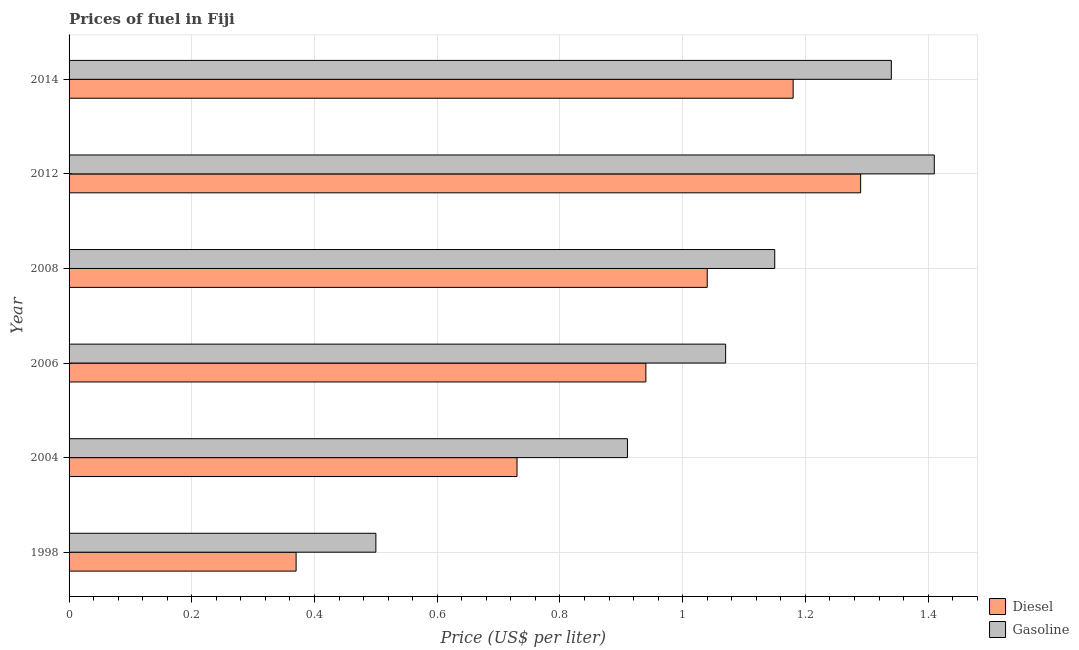How many groups of bars are there?
Give a very brief answer. 6. Are the number of bars per tick equal to the number of legend labels?
Your response must be concise. Yes. Are the number of bars on each tick of the Y-axis equal?
Your response must be concise. Yes. How many bars are there on the 6th tick from the top?
Your answer should be very brief. 2. How many bars are there on the 1st tick from the bottom?
Provide a succinct answer. 2. What is the gasoline price in 2014?
Make the answer very short. 1.34. Across all years, what is the maximum diesel price?
Keep it short and to the point. 1.29. Across all years, what is the minimum diesel price?
Your answer should be compact. 0.37. In which year was the diesel price maximum?
Give a very brief answer. 2012. In which year was the diesel price minimum?
Your response must be concise. 1998. What is the total gasoline price in the graph?
Your response must be concise. 6.38. What is the difference between the gasoline price in 2004 and that in 2008?
Provide a succinct answer. -0.24. What is the difference between the gasoline price in 2008 and the diesel price in 2004?
Offer a very short reply. 0.42. What is the average diesel price per year?
Provide a short and direct response. 0.93. In the year 2006, what is the difference between the gasoline price and diesel price?
Provide a short and direct response. 0.13. What is the ratio of the diesel price in 2008 to that in 2012?
Make the answer very short. 0.81. Is the gasoline price in 2012 less than that in 2014?
Your answer should be very brief. No. Is the difference between the gasoline price in 2004 and 2008 greater than the difference between the diesel price in 2004 and 2008?
Provide a succinct answer. Yes. What is the difference between the highest and the second highest gasoline price?
Offer a terse response. 0.07. What is the difference between the highest and the lowest gasoline price?
Your response must be concise. 0.91. In how many years, is the diesel price greater than the average diesel price taken over all years?
Your answer should be compact. 4. Is the sum of the diesel price in 1998 and 2014 greater than the maximum gasoline price across all years?
Provide a short and direct response. Yes. What does the 1st bar from the top in 2006 represents?
Your response must be concise. Gasoline. What does the 1st bar from the bottom in 2008 represents?
Make the answer very short. Diesel. How many years are there in the graph?
Provide a short and direct response. 6. What is the difference between two consecutive major ticks on the X-axis?
Your answer should be very brief. 0.2. Where does the legend appear in the graph?
Offer a terse response. Bottom right. What is the title of the graph?
Provide a short and direct response. Prices of fuel in Fiji. Does "RDB concessional" appear as one of the legend labels in the graph?
Provide a succinct answer. No. What is the label or title of the X-axis?
Offer a terse response. Price (US$ per liter). What is the label or title of the Y-axis?
Make the answer very short. Year. What is the Price (US$ per liter) in Diesel in 1998?
Offer a very short reply. 0.37. What is the Price (US$ per liter) in Gasoline in 1998?
Offer a terse response. 0.5. What is the Price (US$ per liter) of Diesel in 2004?
Your response must be concise. 0.73. What is the Price (US$ per liter) in Gasoline in 2004?
Make the answer very short. 0.91. What is the Price (US$ per liter) of Gasoline in 2006?
Offer a terse response. 1.07. What is the Price (US$ per liter) of Diesel in 2008?
Your answer should be compact. 1.04. What is the Price (US$ per liter) in Gasoline in 2008?
Ensure brevity in your answer.  1.15. What is the Price (US$ per liter) in Diesel in 2012?
Your answer should be very brief. 1.29. What is the Price (US$ per liter) of Gasoline in 2012?
Give a very brief answer. 1.41. What is the Price (US$ per liter) in Diesel in 2014?
Provide a succinct answer. 1.18. What is the Price (US$ per liter) in Gasoline in 2014?
Provide a short and direct response. 1.34. Across all years, what is the maximum Price (US$ per liter) of Diesel?
Provide a short and direct response. 1.29. Across all years, what is the maximum Price (US$ per liter) in Gasoline?
Keep it short and to the point. 1.41. Across all years, what is the minimum Price (US$ per liter) in Diesel?
Ensure brevity in your answer.  0.37. Across all years, what is the minimum Price (US$ per liter) in Gasoline?
Provide a short and direct response. 0.5. What is the total Price (US$ per liter) in Diesel in the graph?
Give a very brief answer. 5.55. What is the total Price (US$ per liter) of Gasoline in the graph?
Your answer should be compact. 6.38. What is the difference between the Price (US$ per liter) in Diesel in 1998 and that in 2004?
Offer a very short reply. -0.36. What is the difference between the Price (US$ per liter) of Gasoline in 1998 and that in 2004?
Provide a succinct answer. -0.41. What is the difference between the Price (US$ per liter) in Diesel in 1998 and that in 2006?
Your answer should be very brief. -0.57. What is the difference between the Price (US$ per liter) in Gasoline in 1998 and that in 2006?
Provide a short and direct response. -0.57. What is the difference between the Price (US$ per liter) in Diesel in 1998 and that in 2008?
Provide a succinct answer. -0.67. What is the difference between the Price (US$ per liter) in Gasoline in 1998 and that in 2008?
Offer a terse response. -0.65. What is the difference between the Price (US$ per liter) of Diesel in 1998 and that in 2012?
Ensure brevity in your answer.  -0.92. What is the difference between the Price (US$ per liter) in Gasoline in 1998 and that in 2012?
Your response must be concise. -0.91. What is the difference between the Price (US$ per liter) in Diesel in 1998 and that in 2014?
Ensure brevity in your answer.  -0.81. What is the difference between the Price (US$ per liter) of Gasoline in 1998 and that in 2014?
Keep it short and to the point. -0.84. What is the difference between the Price (US$ per liter) of Diesel in 2004 and that in 2006?
Provide a short and direct response. -0.21. What is the difference between the Price (US$ per liter) of Gasoline in 2004 and that in 2006?
Provide a short and direct response. -0.16. What is the difference between the Price (US$ per liter) in Diesel in 2004 and that in 2008?
Make the answer very short. -0.31. What is the difference between the Price (US$ per liter) of Gasoline in 2004 and that in 2008?
Provide a short and direct response. -0.24. What is the difference between the Price (US$ per liter) of Diesel in 2004 and that in 2012?
Provide a short and direct response. -0.56. What is the difference between the Price (US$ per liter) of Gasoline in 2004 and that in 2012?
Provide a short and direct response. -0.5. What is the difference between the Price (US$ per liter) of Diesel in 2004 and that in 2014?
Provide a short and direct response. -0.45. What is the difference between the Price (US$ per liter) of Gasoline in 2004 and that in 2014?
Provide a short and direct response. -0.43. What is the difference between the Price (US$ per liter) of Diesel in 2006 and that in 2008?
Offer a very short reply. -0.1. What is the difference between the Price (US$ per liter) of Gasoline in 2006 and that in 2008?
Ensure brevity in your answer.  -0.08. What is the difference between the Price (US$ per liter) in Diesel in 2006 and that in 2012?
Your answer should be very brief. -0.35. What is the difference between the Price (US$ per liter) of Gasoline in 2006 and that in 2012?
Ensure brevity in your answer.  -0.34. What is the difference between the Price (US$ per liter) of Diesel in 2006 and that in 2014?
Offer a very short reply. -0.24. What is the difference between the Price (US$ per liter) of Gasoline in 2006 and that in 2014?
Offer a terse response. -0.27. What is the difference between the Price (US$ per liter) of Diesel in 2008 and that in 2012?
Keep it short and to the point. -0.25. What is the difference between the Price (US$ per liter) of Gasoline in 2008 and that in 2012?
Ensure brevity in your answer.  -0.26. What is the difference between the Price (US$ per liter) in Diesel in 2008 and that in 2014?
Give a very brief answer. -0.14. What is the difference between the Price (US$ per liter) in Gasoline in 2008 and that in 2014?
Offer a very short reply. -0.19. What is the difference between the Price (US$ per liter) of Diesel in 2012 and that in 2014?
Offer a terse response. 0.11. What is the difference between the Price (US$ per liter) of Gasoline in 2012 and that in 2014?
Make the answer very short. 0.07. What is the difference between the Price (US$ per liter) of Diesel in 1998 and the Price (US$ per liter) of Gasoline in 2004?
Keep it short and to the point. -0.54. What is the difference between the Price (US$ per liter) of Diesel in 1998 and the Price (US$ per liter) of Gasoline in 2006?
Your answer should be very brief. -0.7. What is the difference between the Price (US$ per liter) of Diesel in 1998 and the Price (US$ per liter) of Gasoline in 2008?
Make the answer very short. -0.78. What is the difference between the Price (US$ per liter) of Diesel in 1998 and the Price (US$ per liter) of Gasoline in 2012?
Keep it short and to the point. -1.04. What is the difference between the Price (US$ per liter) of Diesel in 1998 and the Price (US$ per liter) of Gasoline in 2014?
Keep it short and to the point. -0.97. What is the difference between the Price (US$ per liter) of Diesel in 2004 and the Price (US$ per liter) of Gasoline in 2006?
Offer a terse response. -0.34. What is the difference between the Price (US$ per liter) in Diesel in 2004 and the Price (US$ per liter) in Gasoline in 2008?
Your answer should be compact. -0.42. What is the difference between the Price (US$ per liter) in Diesel in 2004 and the Price (US$ per liter) in Gasoline in 2012?
Give a very brief answer. -0.68. What is the difference between the Price (US$ per liter) in Diesel in 2004 and the Price (US$ per liter) in Gasoline in 2014?
Provide a short and direct response. -0.61. What is the difference between the Price (US$ per liter) of Diesel in 2006 and the Price (US$ per liter) of Gasoline in 2008?
Give a very brief answer. -0.21. What is the difference between the Price (US$ per liter) of Diesel in 2006 and the Price (US$ per liter) of Gasoline in 2012?
Give a very brief answer. -0.47. What is the difference between the Price (US$ per liter) in Diesel in 2008 and the Price (US$ per liter) in Gasoline in 2012?
Your response must be concise. -0.37. What is the difference between the Price (US$ per liter) in Diesel in 2008 and the Price (US$ per liter) in Gasoline in 2014?
Your answer should be very brief. -0.3. What is the average Price (US$ per liter) in Diesel per year?
Ensure brevity in your answer.  0.93. What is the average Price (US$ per liter) in Gasoline per year?
Your answer should be compact. 1.06. In the year 1998, what is the difference between the Price (US$ per liter) in Diesel and Price (US$ per liter) in Gasoline?
Your response must be concise. -0.13. In the year 2004, what is the difference between the Price (US$ per liter) in Diesel and Price (US$ per liter) in Gasoline?
Provide a succinct answer. -0.18. In the year 2006, what is the difference between the Price (US$ per liter) in Diesel and Price (US$ per liter) in Gasoline?
Offer a very short reply. -0.13. In the year 2008, what is the difference between the Price (US$ per liter) in Diesel and Price (US$ per liter) in Gasoline?
Keep it short and to the point. -0.11. In the year 2012, what is the difference between the Price (US$ per liter) of Diesel and Price (US$ per liter) of Gasoline?
Make the answer very short. -0.12. In the year 2014, what is the difference between the Price (US$ per liter) of Diesel and Price (US$ per liter) of Gasoline?
Ensure brevity in your answer.  -0.16. What is the ratio of the Price (US$ per liter) of Diesel in 1998 to that in 2004?
Give a very brief answer. 0.51. What is the ratio of the Price (US$ per liter) of Gasoline in 1998 to that in 2004?
Provide a succinct answer. 0.55. What is the ratio of the Price (US$ per liter) in Diesel in 1998 to that in 2006?
Make the answer very short. 0.39. What is the ratio of the Price (US$ per liter) of Gasoline in 1998 to that in 2006?
Provide a short and direct response. 0.47. What is the ratio of the Price (US$ per liter) in Diesel in 1998 to that in 2008?
Offer a very short reply. 0.36. What is the ratio of the Price (US$ per liter) of Gasoline in 1998 to that in 2008?
Give a very brief answer. 0.43. What is the ratio of the Price (US$ per liter) in Diesel in 1998 to that in 2012?
Your answer should be very brief. 0.29. What is the ratio of the Price (US$ per liter) in Gasoline in 1998 to that in 2012?
Give a very brief answer. 0.35. What is the ratio of the Price (US$ per liter) of Diesel in 1998 to that in 2014?
Your answer should be compact. 0.31. What is the ratio of the Price (US$ per liter) of Gasoline in 1998 to that in 2014?
Ensure brevity in your answer.  0.37. What is the ratio of the Price (US$ per liter) of Diesel in 2004 to that in 2006?
Give a very brief answer. 0.78. What is the ratio of the Price (US$ per liter) in Gasoline in 2004 to that in 2006?
Offer a terse response. 0.85. What is the ratio of the Price (US$ per liter) in Diesel in 2004 to that in 2008?
Provide a succinct answer. 0.7. What is the ratio of the Price (US$ per liter) of Gasoline in 2004 to that in 2008?
Provide a short and direct response. 0.79. What is the ratio of the Price (US$ per liter) in Diesel in 2004 to that in 2012?
Provide a short and direct response. 0.57. What is the ratio of the Price (US$ per liter) of Gasoline in 2004 to that in 2012?
Keep it short and to the point. 0.65. What is the ratio of the Price (US$ per liter) of Diesel in 2004 to that in 2014?
Provide a short and direct response. 0.62. What is the ratio of the Price (US$ per liter) in Gasoline in 2004 to that in 2014?
Your answer should be very brief. 0.68. What is the ratio of the Price (US$ per liter) of Diesel in 2006 to that in 2008?
Give a very brief answer. 0.9. What is the ratio of the Price (US$ per liter) of Gasoline in 2006 to that in 2008?
Provide a succinct answer. 0.93. What is the ratio of the Price (US$ per liter) of Diesel in 2006 to that in 2012?
Provide a succinct answer. 0.73. What is the ratio of the Price (US$ per liter) in Gasoline in 2006 to that in 2012?
Offer a very short reply. 0.76. What is the ratio of the Price (US$ per liter) of Diesel in 2006 to that in 2014?
Provide a short and direct response. 0.8. What is the ratio of the Price (US$ per liter) in Gasoline in 2006 to that in 2014?
Offer a very short reply. 0.8. What is the ratio of the Price (US$ per liter) of Diesel in 2008 to that in 2012?
Give a very brief answer. 0.81. What is the ratio of the Price (US$ per liter) in Gasoline in 2008 to that in 2012?
Provide a short and direct response. 0.82. What is the ratio of the Price (US$ per liter) of Diesel in 2008 to that in 2014?
Offer a terse response. 0.88. What is the ratio of the Price (US$ per liter) of Gasoline in 2008 to that in 2014?
Provide a short and direct response. 0.86. What is the ratio of the Price (US$ per liter) in Diesel in 2012 to that in 2014?
Provide a short and direct response. 1.09. What is the ratio of the Price (US$ per liter) of Gasoline in 2012 to that in 2014?
Your answer should be very brief. 1.05. What is the difference between the highest and the second highest Price (US$ per liter) of Diesel?
Give a very brief answer. 0.11. What is the difference between the highest and the second highest Price (US$ per liter) of Gasoline?
Your response must be concise. 0.07. What is the difference between the highest and the lowest Price (US$ per liter) in Diesel?
Give a very brief answer. 0.92. What is the difference between the highest and the lowest Price (US$ per liter) of Gasoline?
Provide a succinct answer. 0.91. 